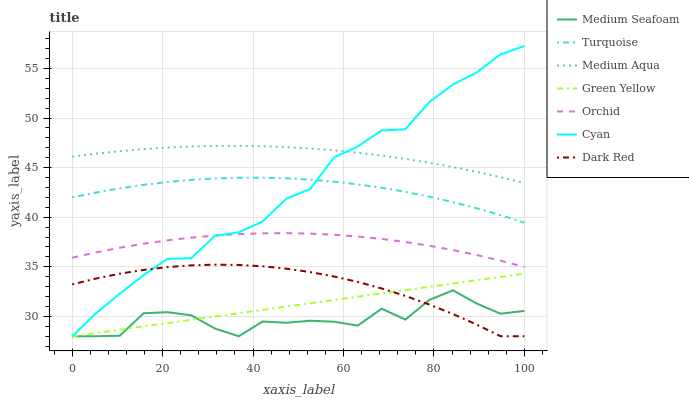Does Medium Seafoam have the minimum area under the curve?
Answer yes or no. Yes. Does Medium Aqua have the maximum area under the curve?
Answer yes or no. Yes. Does Dark Red have the minimum area under the curve?
Answer yes or no. No. Does Dark Red have the maximum area under the curve?
Answer yes or no. No. Is Green Yellow the smoothest?
Answer yes or no. Yes. Is Medium Seafoam the roughest?
Answer yes or no. Yes. Is Dark Red the smoothest?
Answer yes or no. No. Is Dark Red the roughest?
Answer yes or no. No. Does Dark Red have the lowest value?
Answer yes or no. Yes. Does Medium Aqua have the lowest value?
Answer yes or no. No. Does Cyan have the highest value?
Answer yes or no. Yes. Does Dark Red have the highest value?
Answer yes or no. No. Is Orchid less than Turquoise?
Answer yes or no. Yes. Is Turquoise greater than Green Yellow?
Answer yes or no. Yes. Does Cyan intersect Turquoise?
Answer yes or no. Yes. Is Cyan less than Turquoise?
Answer yes or no. No. Is Cyan greater than Turquoise?
Answer yes or no. No. Does Orchid intersect Turquoise?
Answer yes or no. No. 